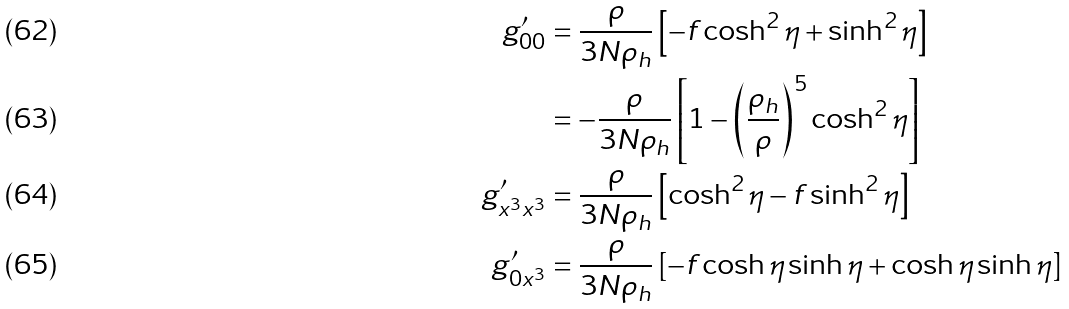<formula> <loc_0><loc_0><loc_500><loc_500>g ^ { \prime } _ { 0 0 } & = \frac { \rho } { 3 N \rho _ { h } } \left [ - f \cosh ^ { 2 } \eta + \sinh ^ { 2 } \eta \right ] \\ & = - \frac { \rho } { 3 N \rho _ { h } } \left [ 1 - \left ( \frac { \rho _ { h } } { \rho } \right ) ^ { 5 } \cosh ^ { 2 } \eta \right ] \\ g ^ { \prime } _ { x ^ { 3 } x ^ { 3 } } & = \frac { \rho } { 3 N \rho _ { h } } \left [ \cosh ^ { 2 } \eta - f \sinh ^ { 2 } \eta \right ] \\ g ^ { \prime } _ { 0 x ^ { 3 } } & = \frac { \rho } { 3 N \rho _ { h } } \left [ - f \cosh \eta \sinh \eta + \cosh \eta \sinh \eta \right ]</formula> 